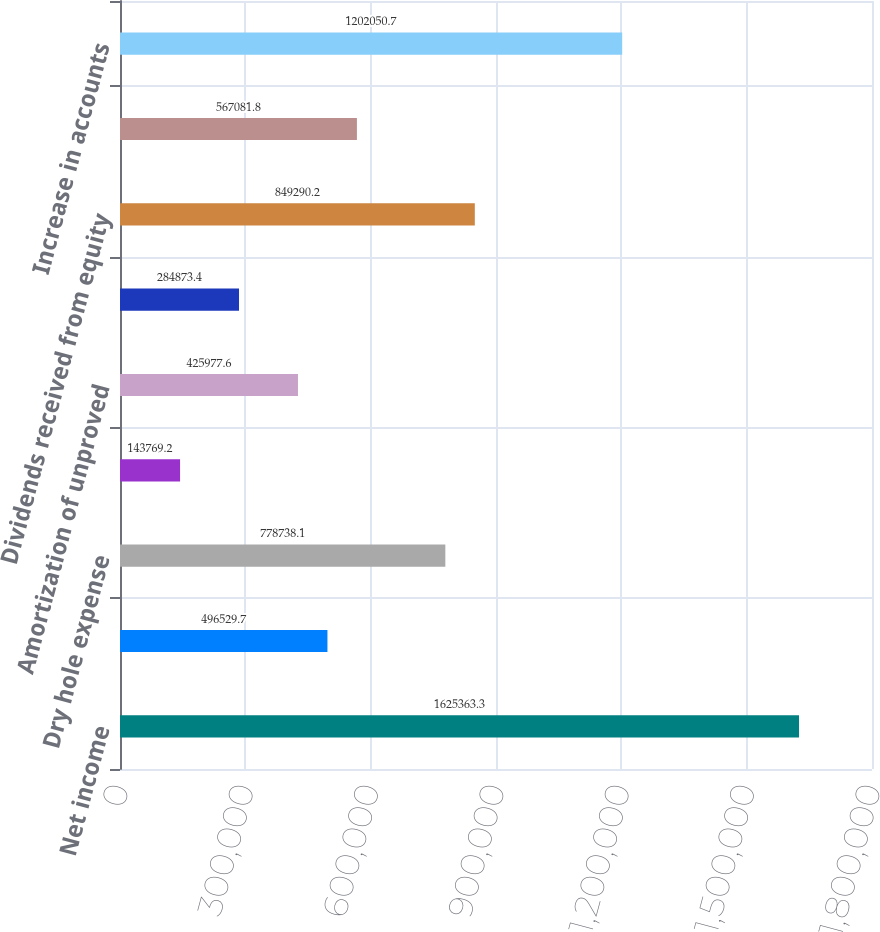Convert chart to OTSL. <chart><loc_0><loc_0><loc_500><loc_500><bar_chart><fcel>Net income<fcel>Depreciation depletion and<fcel>Dry hole expense<fcel>Impairment of operating assets<fcel>Amortization of unproved<fcel>Deferred income taxes<fcel>Dividends received from equity<fcel>Other<fcel>Increase in accounts<nl><fcel>1.62536e+06<fcel>496530<fcel>778738<fcel>143769<fcel>425978<fcel>284873<fcel>849290<fcel>567082<fcel>1.20205e+06<nl></chart> 